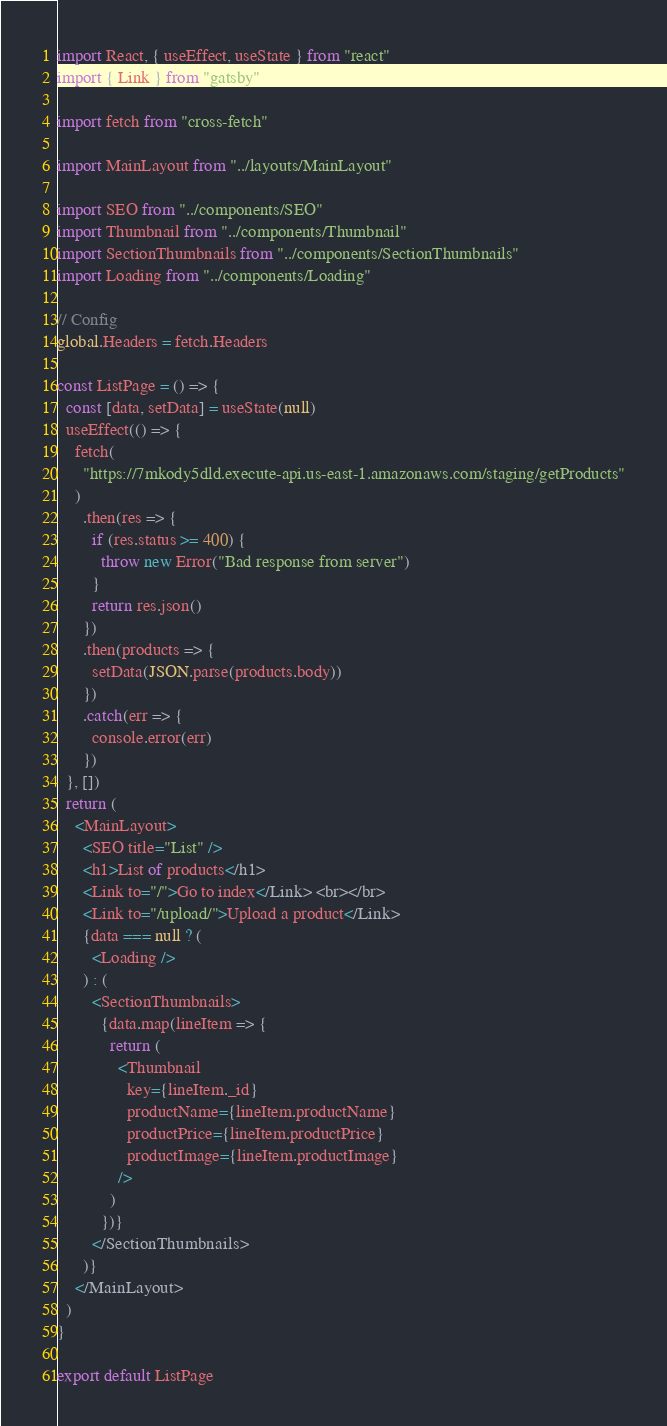<code> <loc_0><loc_0><loc_500><loc_500><_JavaScript_>import React, { useEffect, useState } from "react"
import { Link } from "gatsby"

import fetch from "cross-fetch"

import MainLayout from "../layouts/MainLayout"

import SEO from "../components/SEO"
import Thumbnail from "../components/Thumbnail"
import SectionThumbnails from "../components/SectionThumbnails"
import Loading from "../components/Loading"

// Config
global.Headers = fetch.Headers

const ListPage = () => {
  const [data, setData] = useState(null)
  useEffect(() => {
    fetch(
      "https://7mkody5dld.execute-api.us-east-1.amazonaws.com/staging/getProducts"
    )
      .then(res => {
        if (res.status >= 400) {
          throw new Error("Bad response from server")
        }
        return res.json()
      })
      .then(products => {
        setData(JSON.parse(products.body))
      })
      .catch(err => {
        console.error(err)
      })
  }, [])
  return (
    <MainLayout>
      <SEO title="List" />
      <h1>List of products</h1>
      <Link to="/">Go to index</Link> <br></br>
      <Link to="/upload/">Upload a product</Link>
      {data === null ? (
        <Loading />
      ) : (
        <SectionThumbnails>
          {data.map(lineItem => {
            return (
              <Thumbnail
                key={lineItem._id}
                productName={lineItem.productName}
                productPrice={lineItem.productPrice}
                productImage={lineItem.productImage}
              />
            )
          })}
        </SectionThumbnails>
      )}
    </MainLayout>
  )
}

export default ListPage
</code> 